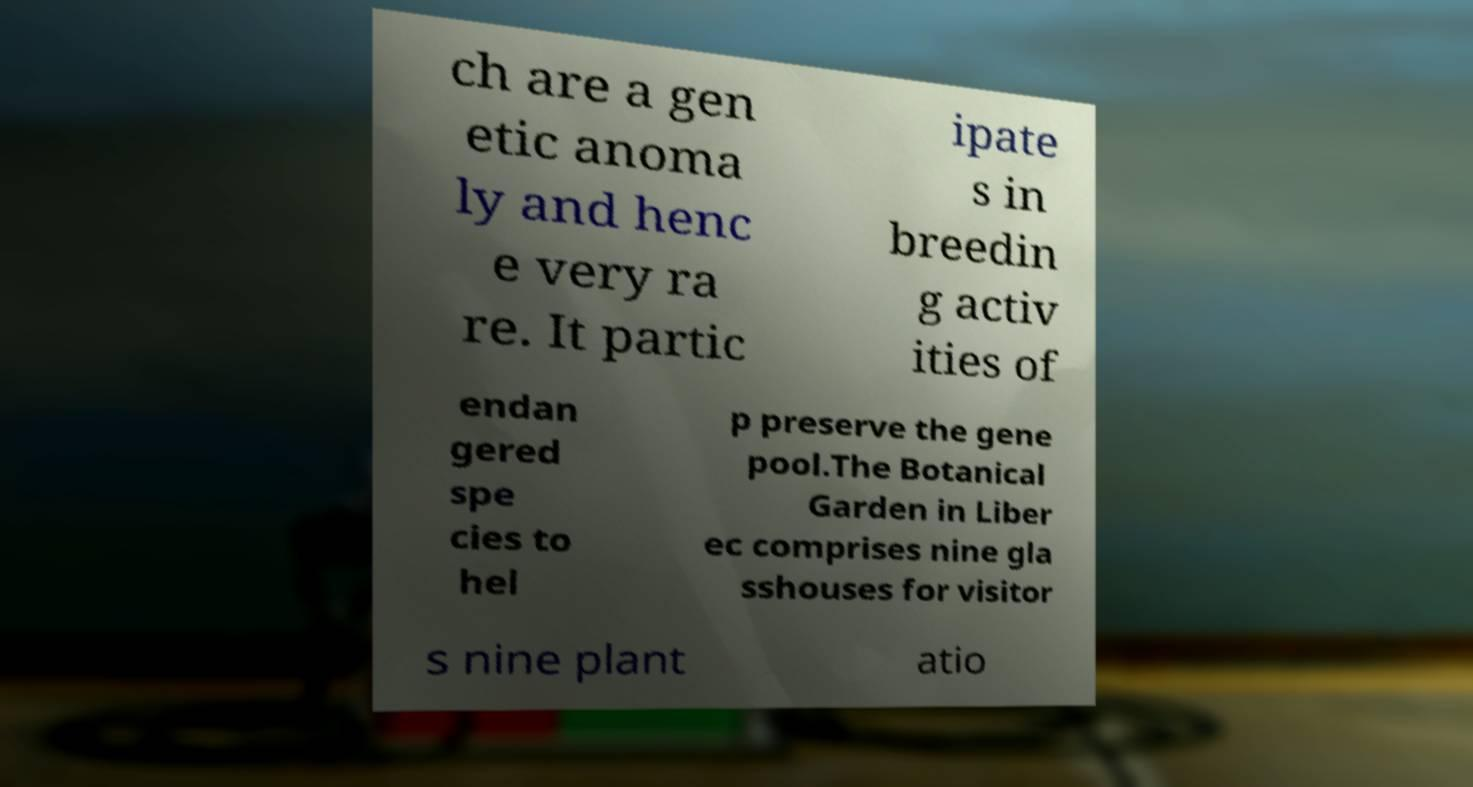Can you read and provide the text displayed in the image?This photo seems to have some interesting text. Can you extract and type it out for me? ch are a gen etic anoma ly and henc e very ra re. It partic ipate s in breedin g activ ities of endan gered spe cies to hel p preserve the gene pool.The Botanical Garden in Liber ec comprises nine gla sshouses for visitor s nine plant atio 